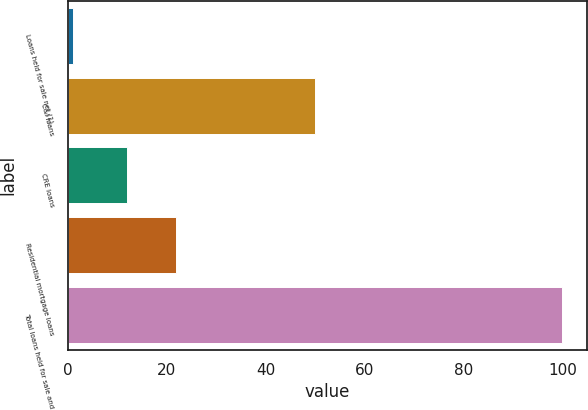Convert chart. <chart><loc_0><loc_0><loc_500><loc_500><bar_chart><fcel>Loans held for sale net (1)<fcel>C&I loans<fcel>CRE loans<fcel>Residential mortgage loans<fcel>Total loans held for sale and<nl><fcel>1<fcel>50<fcel>12<fcel>21.9<fcel>100<nl></chart> 